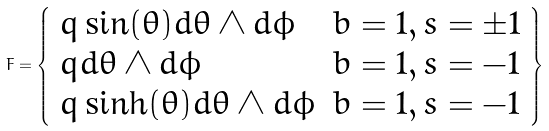Convert formula to latex. <formula><loc_0><loc_0><loc_500><loc_500>F = \left \{ \begin{array} { l l } q \sin ( \theta ) d \theta \wedge d \phi & b = 1 , s = \pm 1 \\ q d \theta \wedge d \phi & b = 1 , s = - 1 \\ q \sinh ( \theta ) d \theta \wedge d \phi & b = 1 , s = - 1 \\ \end{array} \right \}</formula> 